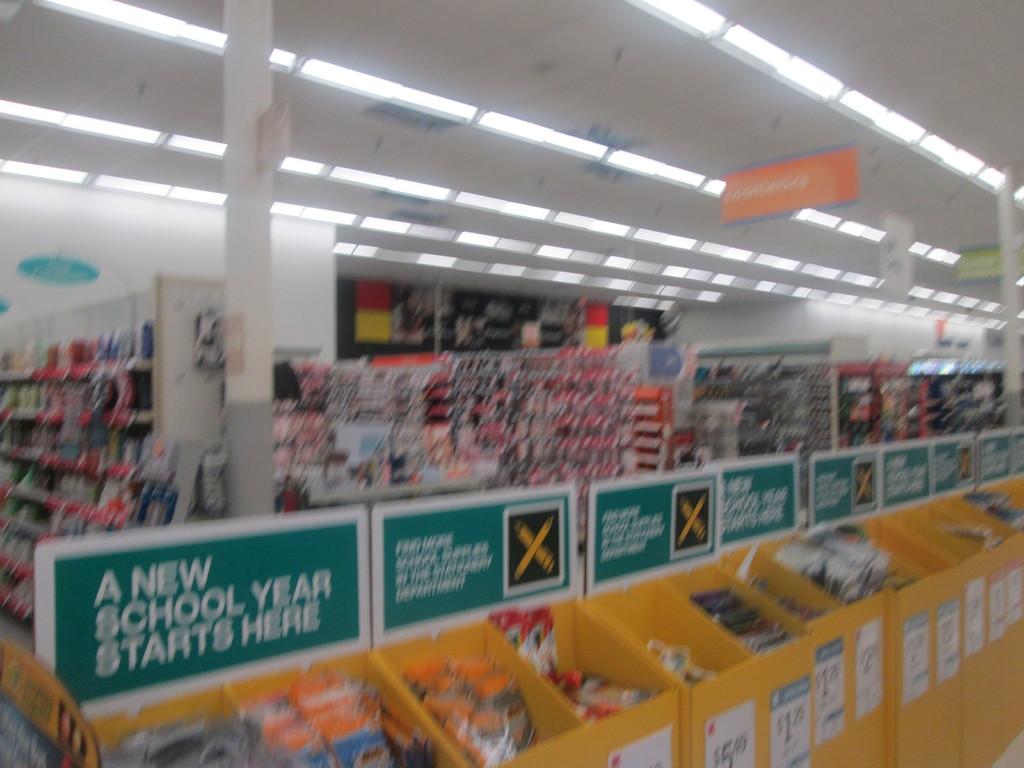What kind of supplies are being sold?
Your answer should be very brief. School. What event is getting ready to take place?
Keep it short and to the point. A new school year. 